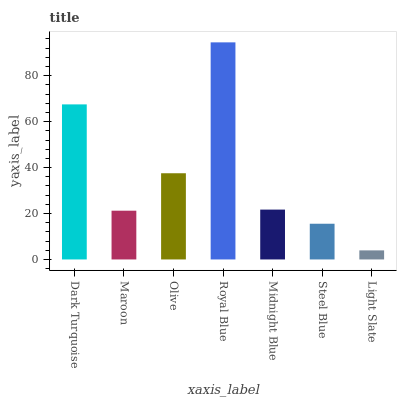Is Light Slate the minimum?
Answer yes or no. Yes. Is Royal Blue the maximum?
Answer yes or no. Yes. Is Maroon the minimum?
Answer yes or no. No. Is Maroon the maximum?
Answer yes or no. No. Is Dark Turquoise greater than Maroon?
Answer yes or no. Yes. Is Maroon less than Dark Turquoise?
Answer yes or no. Yes. Is Maroon greater than Dark Turquoise?
Answer yes or no. No. Is Dark Turquoise less than Maroon?
Answer yes or no. No. Is Midnight Blue the high median?
Answer yes or no. Yes. Is Midnight Blue the low median?
Answer yes or no. Yes. Is Light Slate the high median?
Answer yes or no. No. Is Olive the low median?
Answer yes or no. No. 